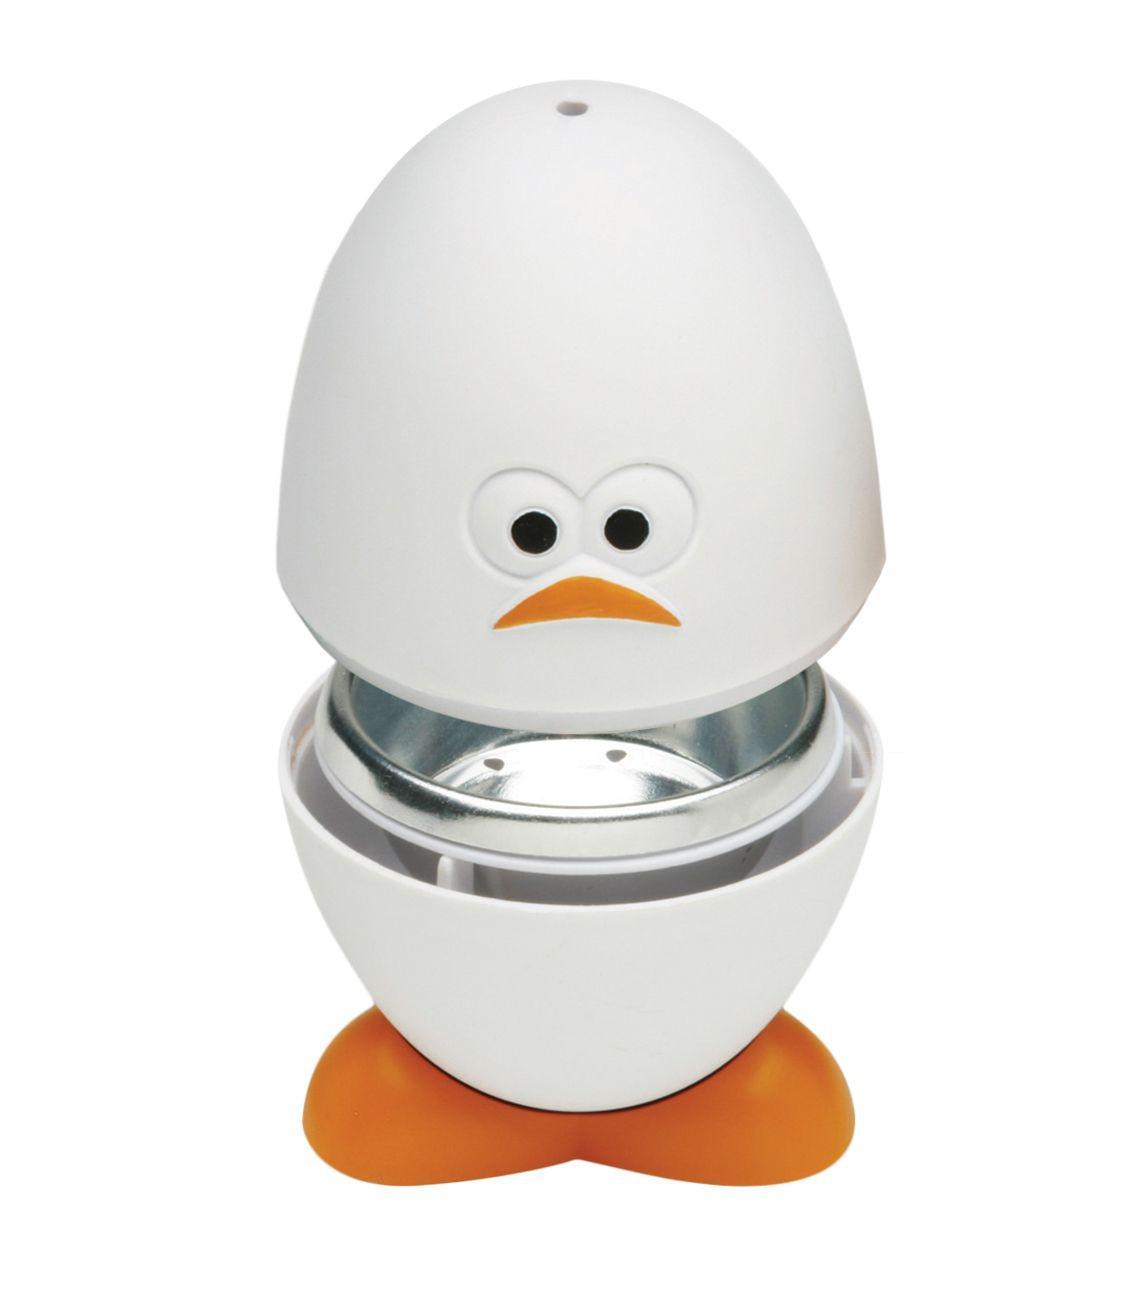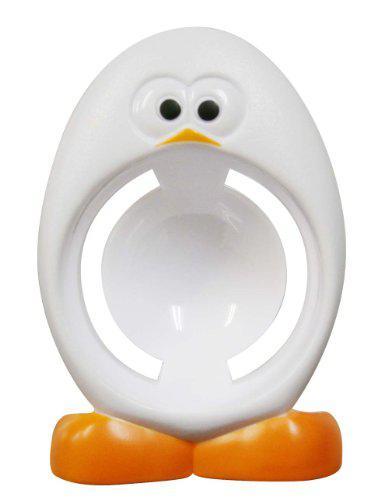The first image is the image on the left, the second image is the image on the right. Given the left and right images, does the statement "One image shows a spoon inserted in yolk in the egg-shaped cup with orange feet." hold true? Answer yes or no. No. 